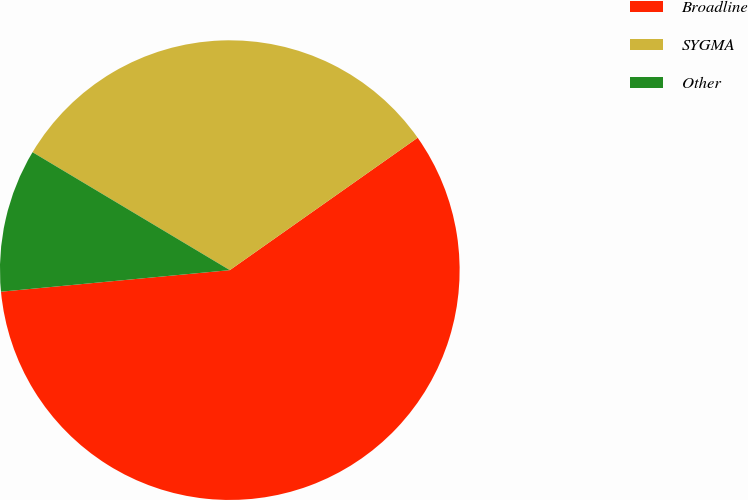Convert chart to OTSL. <chart><loc_0><loc_0><loc_500><loc_500><pie_chart><fcel>Broadline<fcel>SYGMA<fcel>Other<nl><fcel>58.27%<fcel>31.65%<fcel>10.07%<nl></chart> 